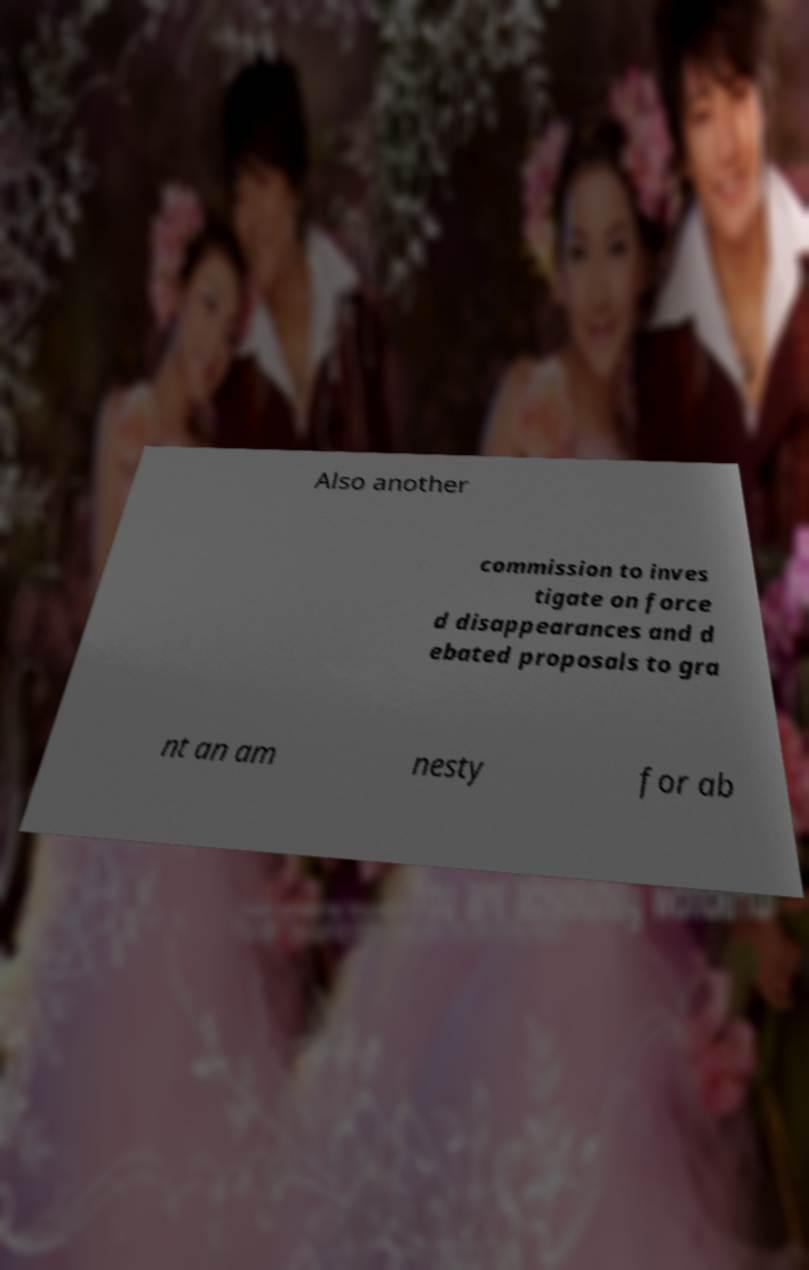Could you extract and type out the text from this image? Also another commission to inves tigate on force d disappearances and d ebated proposals to gra nt an am nesty for ab 